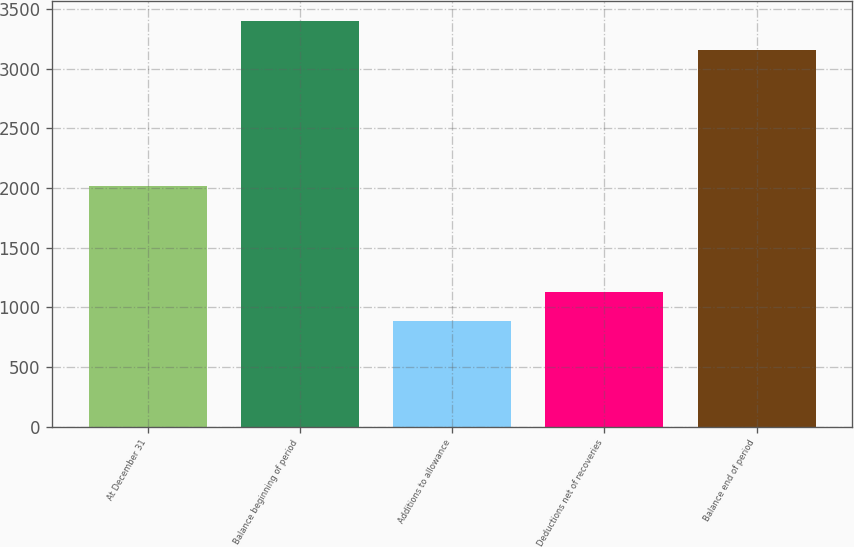<chart> <loc_0><loc_0><loc_500><loc_500><bar_chart><fcel>At December 31<fcel>Balance beginning of period<fcel>Additions to allowance<fcel>Deductions net of recoveries<fcel>Balance end of period<nl><fcel>2016<fcel>3396.8<fcel>890<fcel>1129.8<fcel>3157<nl></chart> 